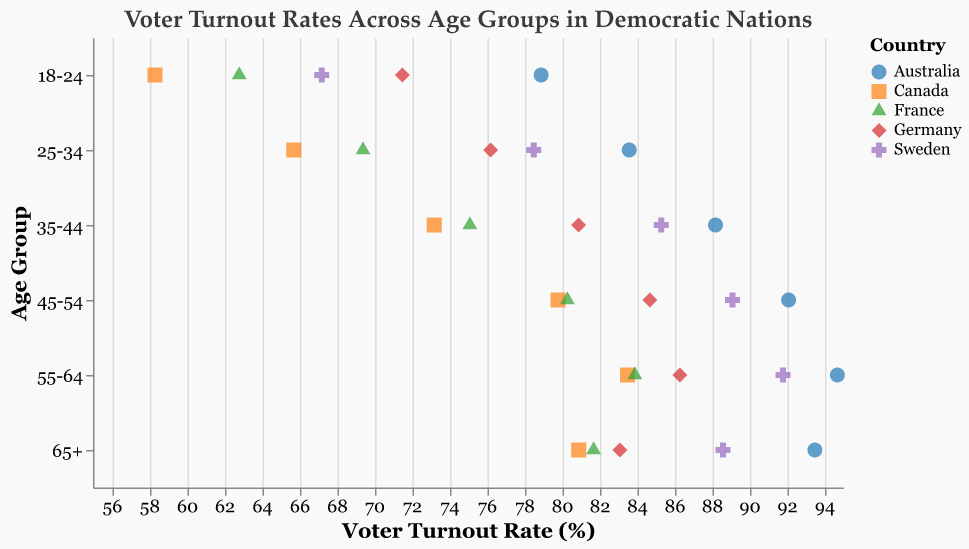What's the voter turnout rate for the 25-34 age group in Germany? Check the horizontal axis labeled "Voter Turnout Rate" and look for the data point corresponding to the 25-34 age group and Germany on the vertical axis. The rate is 76.2%.
Answer: 76.2% Which country has the highest voter turnout rate for the 18-24 age group? Identify the data points for the 18-24 age group and compare their positions along the "Voter Turnout Rate" axis. Australia has the highest rate at 78.9%.
Answer: Australia How does the voter turnout rate for those aged 35-44 in Sweden compare to Canada? Find the data points for the 35-44 age group for both Sweden and Canada, and compare their positions along the "Voter Turnout Rate" axis. Sweden has 85.3% while Canada has 73.2%.
Answer: Sweden is higher What's the average voter turnout rate for the 65+ age group across all countries? Sum the voter turnout rates for the 65+ age group across all countries and divide by the number of countries. (88.6 + 83.1 + 80.9 + 93.5 + 81.7) / 5 = 85.56%
Answer: 85.56% In which age group does France have the lowest voter turnout rate? Identify the lowest voter turnout rate for France by examining all age groups for France on the vertical axis. The lowest turnout rate is in the 18-24 age group at 62.8%.
Answer: 18-24 What's the voter turnout rate difference between the 55-64 and 65+ age groups in Australia? Locate the voter turnout rates for the 55-64 and 65+ age groups in Australia, and subtract the 65+ rate from the 55-64 rate. 94.7% - 93.5% = 1.2%
Answer: 1.2% Which country shows a decline in voter turnout rate from the 55-64 to 65+ age group? Compare the voter turnout rates for the 55-64 and 65+ age groups across all countries. Both Sweden (91.8% to 88.6%) and Germany (86.3% to 83.1%) show a decline.
Answer: Sweden and Germany What is the overall trend of voter turnout rates as age increases across different countries? Observe the patterns in the data points for each country along the age groups from youngest to eldest. Most countries show an increasing trend in voter turnout rates as age increases, with generally higher turnout among older age groups.
Answer: Increasing trend 